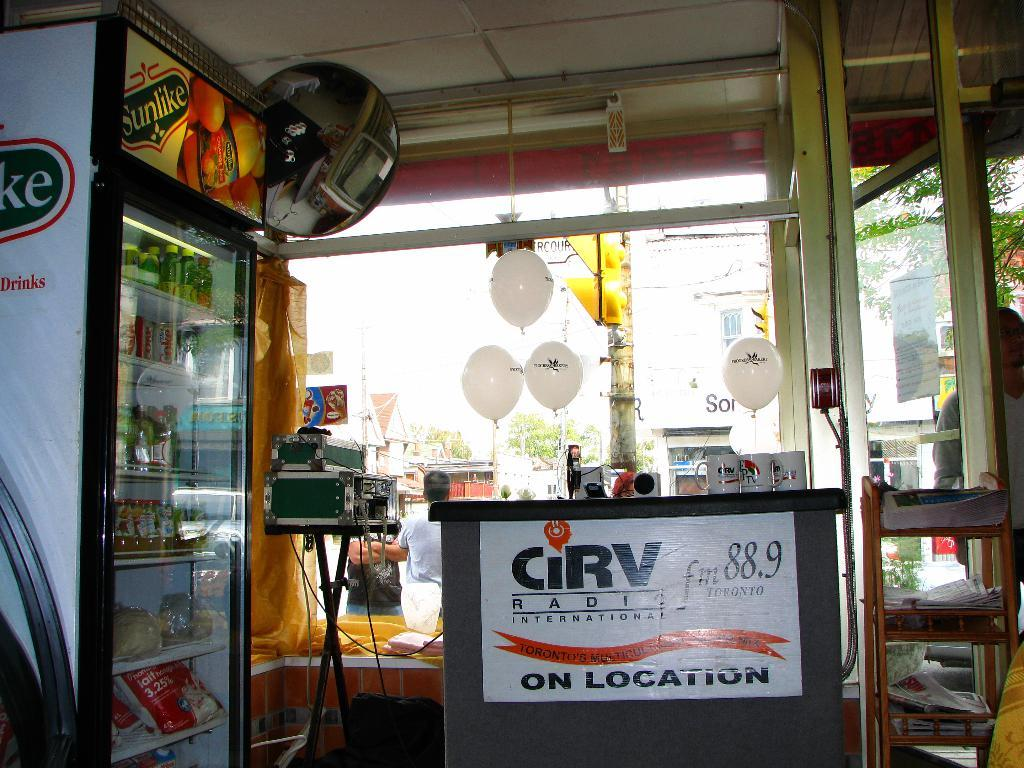Provide a one-sentence caption for the provided image. CiRV radio 88.9 is advertising on a white sign near a Sunlike drink display and cooler. 